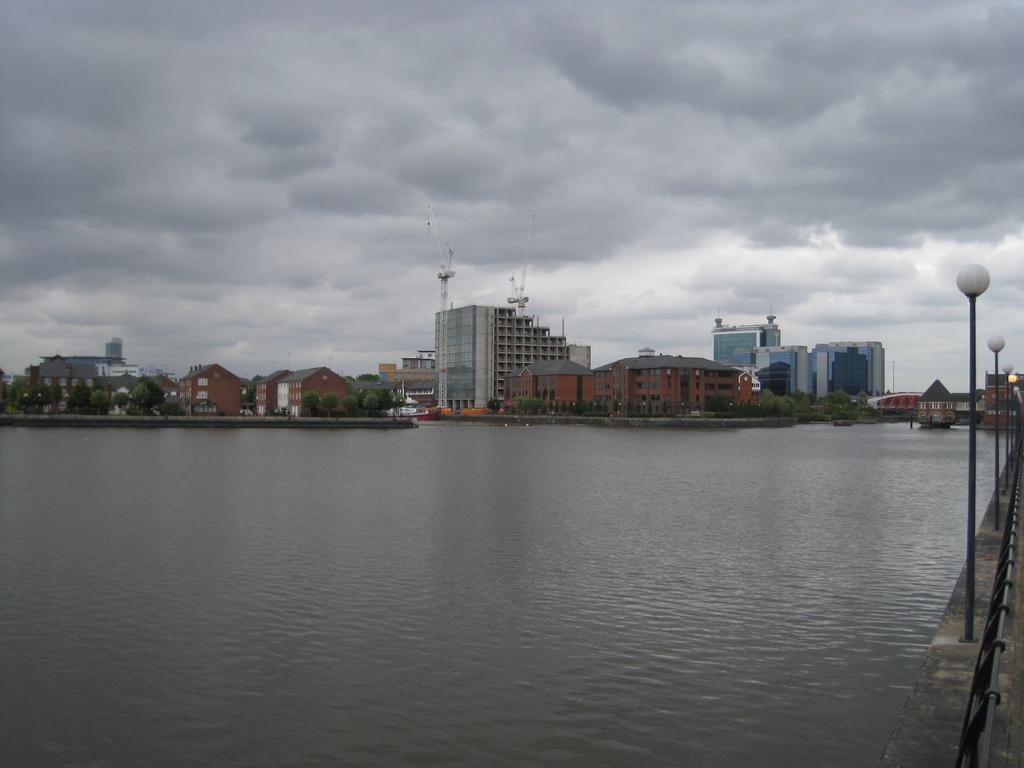Describe this image in one or two sentences. At the bottom of the image there is water. At the right side of the image there is a small wall with railing and also there are poles with lamps. In the background there are trees and buildings with walls and also there are towers on the building. At the top of the image there is a sky with clouds. 